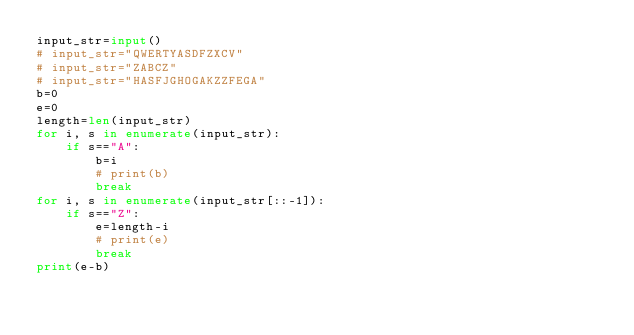Convert code to text. <code><loc_0><loc_0><loc_500><loc_500><_Python_>input_str=input()
# input_str="QWERTYASDFZXCV"
# input_str="ZABCZ"
# input_str="HASFJGHOGAKZZFEGA"
b=0
e=0
length=len(input_str)
for i, s in enumerate(input_str):
	if s=="A":
		b=i
		# print(b)
		break
for i, s in enumerate(input_str[::-1]):
	if s=="Z":
		e=length-i
		# print(e)
		break
print(e-b)
</code> 